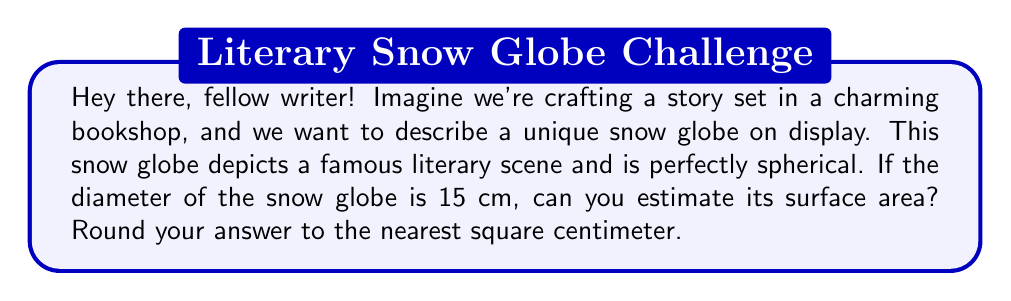What is the answer to this math problem? Certainly! Let's break this down step-by-step:

1) The formula for the surface area of a sphere is:

   $$A = 4\pi r^2$$

   where $A$ is the surface area and $r$ is the radius.

2) We're given the diameter, which is 15 cm. To find the radius, we divide the diameter by 2:

   $$r = \frac{15}{2} = 7.5 \text{ cm}$$

3) Now, let's plug this into our formula:

   $$A = 4\pi (7.5)^2$$

4) Let's calculate:
   
   $$A = 4\pi (56.25)$$
   $$A = 225\pi$$

5) Using 3.14159 as an approximation for $\pi$:

   $$A \approx 225 * 3.14159 = 706.85775 \text{ cm}^2$$

6) Rounding to the nearest square centimeter:

   $$A \approx 707 \text{ cm}^2$$

This surface area represents the amount of glass needed to create the snow globe, which would be crucial information if we were describing the craftsmanship in our story!

[asy]
import geometry;

size(100);
draw(Circle((0,0),1));
draw((0,0)--(1,0),arrow=Arrow(TeXHead));
label("$r$", (0.5,0.1), N);
label("15 cm", (0,-1.2));
[/asy]
Answer: The estimated surface area of the spherical snow globe is approximately 707 cm². 